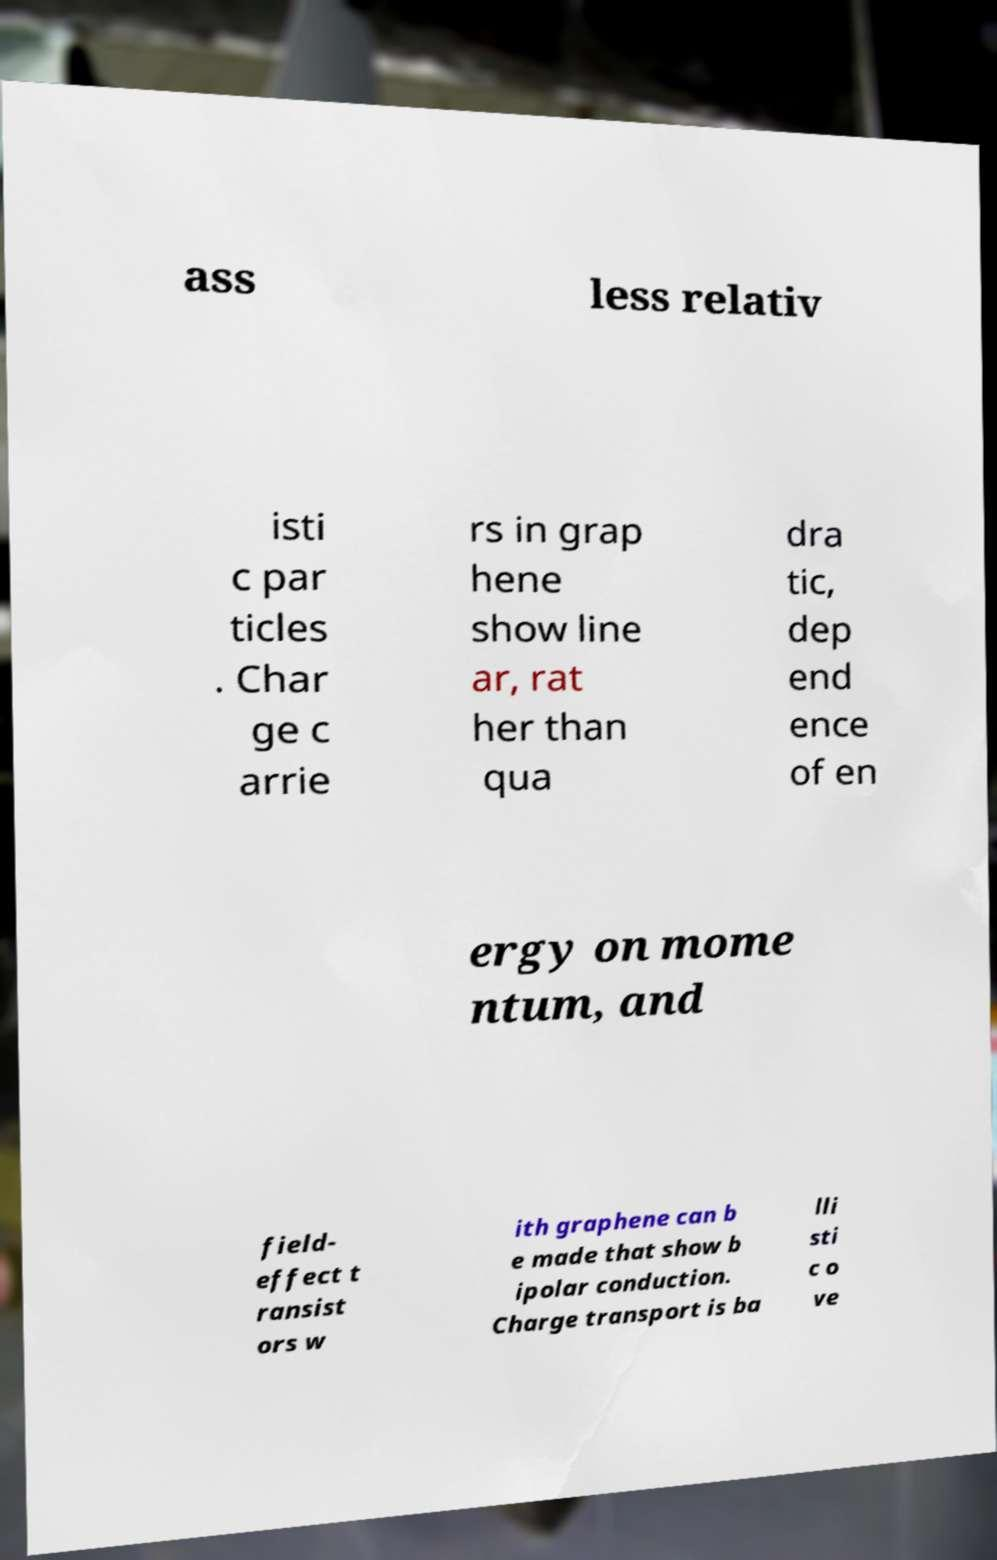Can you read and provide the text displayed in the image?This photo seems to have some interesting text. Can you extract and type it out for me? ass less relativ isti c par ticles . Char ge c arrie rs in grap hene show line ar, rat her than qua dra tic, dep end ence of en ergy on mome ntum, and field- effect t ransist ors w ith graphene can b e made that show b ipolar conduction. Charge transport is ba lli sti c o ve 